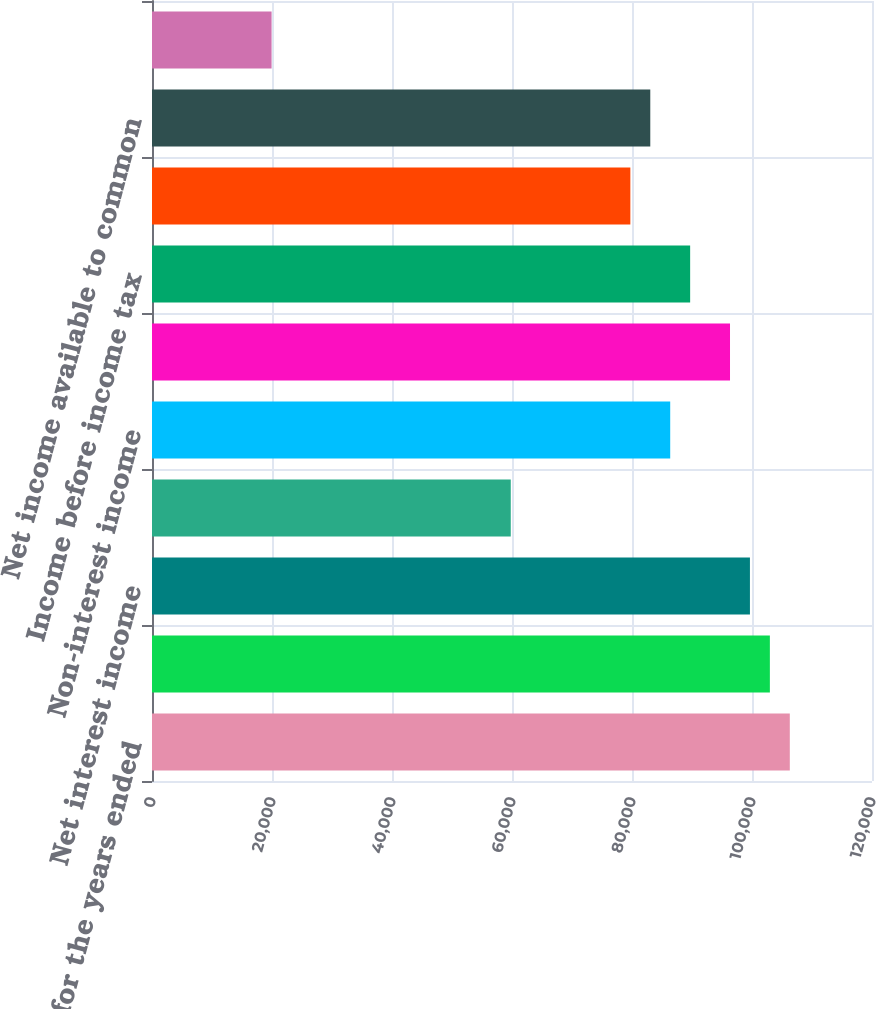<chart> <loc_0><loc_0><loc_500><loc_500><bar_chart><fcel>As of and for the years ended<fcel>Net interest income (fully<fcel>Net interest income<fcel>Provision for loan losses<fcel>Non-interest income<fcel>Non-interest expense (1)<fcel>Income before income tax<fcel>Net income<fcel>Net income available to common<fcel>Net interest margin<nl><fcel>106300<fcel>102978<fcel>99656.6<fcel>59794<fcel>86369.1<fcel>96334.7<fcel>89690.9<fcel>79725.3<fcel>83047.2<fcel>19931.5<nl></chart> 